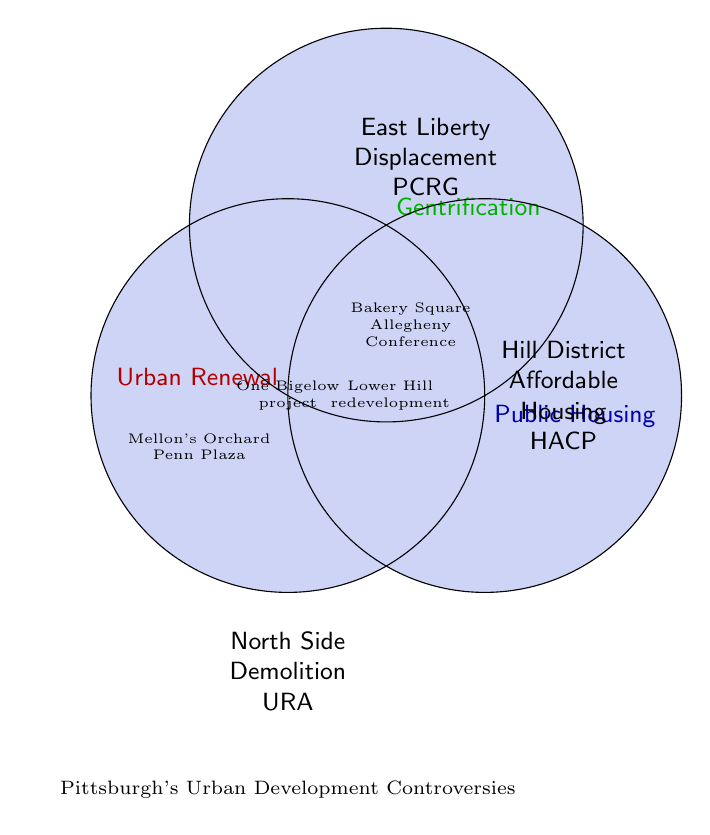Which area is associated with urban renewal, gentrification, and public housing? According to the Venn diagram, the One Bigelow project falls under the intersection of urban renewal, gentrification, and public housing.
Answer: One Bigelow project Which controversies are related to the East Liberty region? In the diagram, the East Liberty region is associated with gentrification and includes controversies related to displacement and the PCRG group. Additionally, Bakery Square is a relevant controversy here.
Answer: Displacement, PCRG, Bakery Square What urban development issues are linked with the North Side? The figure shows that the North Side is associated with urban renewal. Specific issues include demolition and involvement by the URA group.
Answer: Demolition, URA Which specific projects overlap between urban renewal and gentrification? In the Venn diagram, the overlapping region between urban renewal and gentrification mentions Bakery Square and the Allegheny Conference as relevant controversies.
Answer: Bakery Square, Allegheny Conference What are the main concerns in the Hill District related to public housing? The Venn diagram indicates that public housing issues in the Hill District include affordable housing and involvement by the HACP group.
Answer: Affordable Housing, HACP Which areas or projects are associated with public housing and also urban renewal? Lower Hill redevelopment and Larimer/East Liberty Choice projects are mentioned in the overlapping area between public housing and urban renewal.
Answer: Lower Hill redevelopment, Larimer/East Liberty Choice How many exclusive categories are there for urban renewal issues? From the Venn diagram, urban renewal issues that do not overlap with other categories are labeled as North Side, Demolition, and URA. This means there are three exclusive categories for urban renewal.
Answer: Three Is "Mellon's Orchard" associated with more than one controversy? If yes, which ones? The diagram shows that Mellon's Orchard is at the intersection of gentrification and public housing, thus it's associated with both controversies.
Answer: Gentrification and Public Housing Which categories overlap with all three urban development controversies? The only project that falls under the center of the Venn diagram, thus intersecting all three categories (urban renewal, gentrification, public housing), is the One Bigelow project.
Answer: One Bigelow project What kind of controversy is associated with zoning changes? According to the Venn diagram, zoning changes fall under the category of gentrification.
Answer: Gentrification 